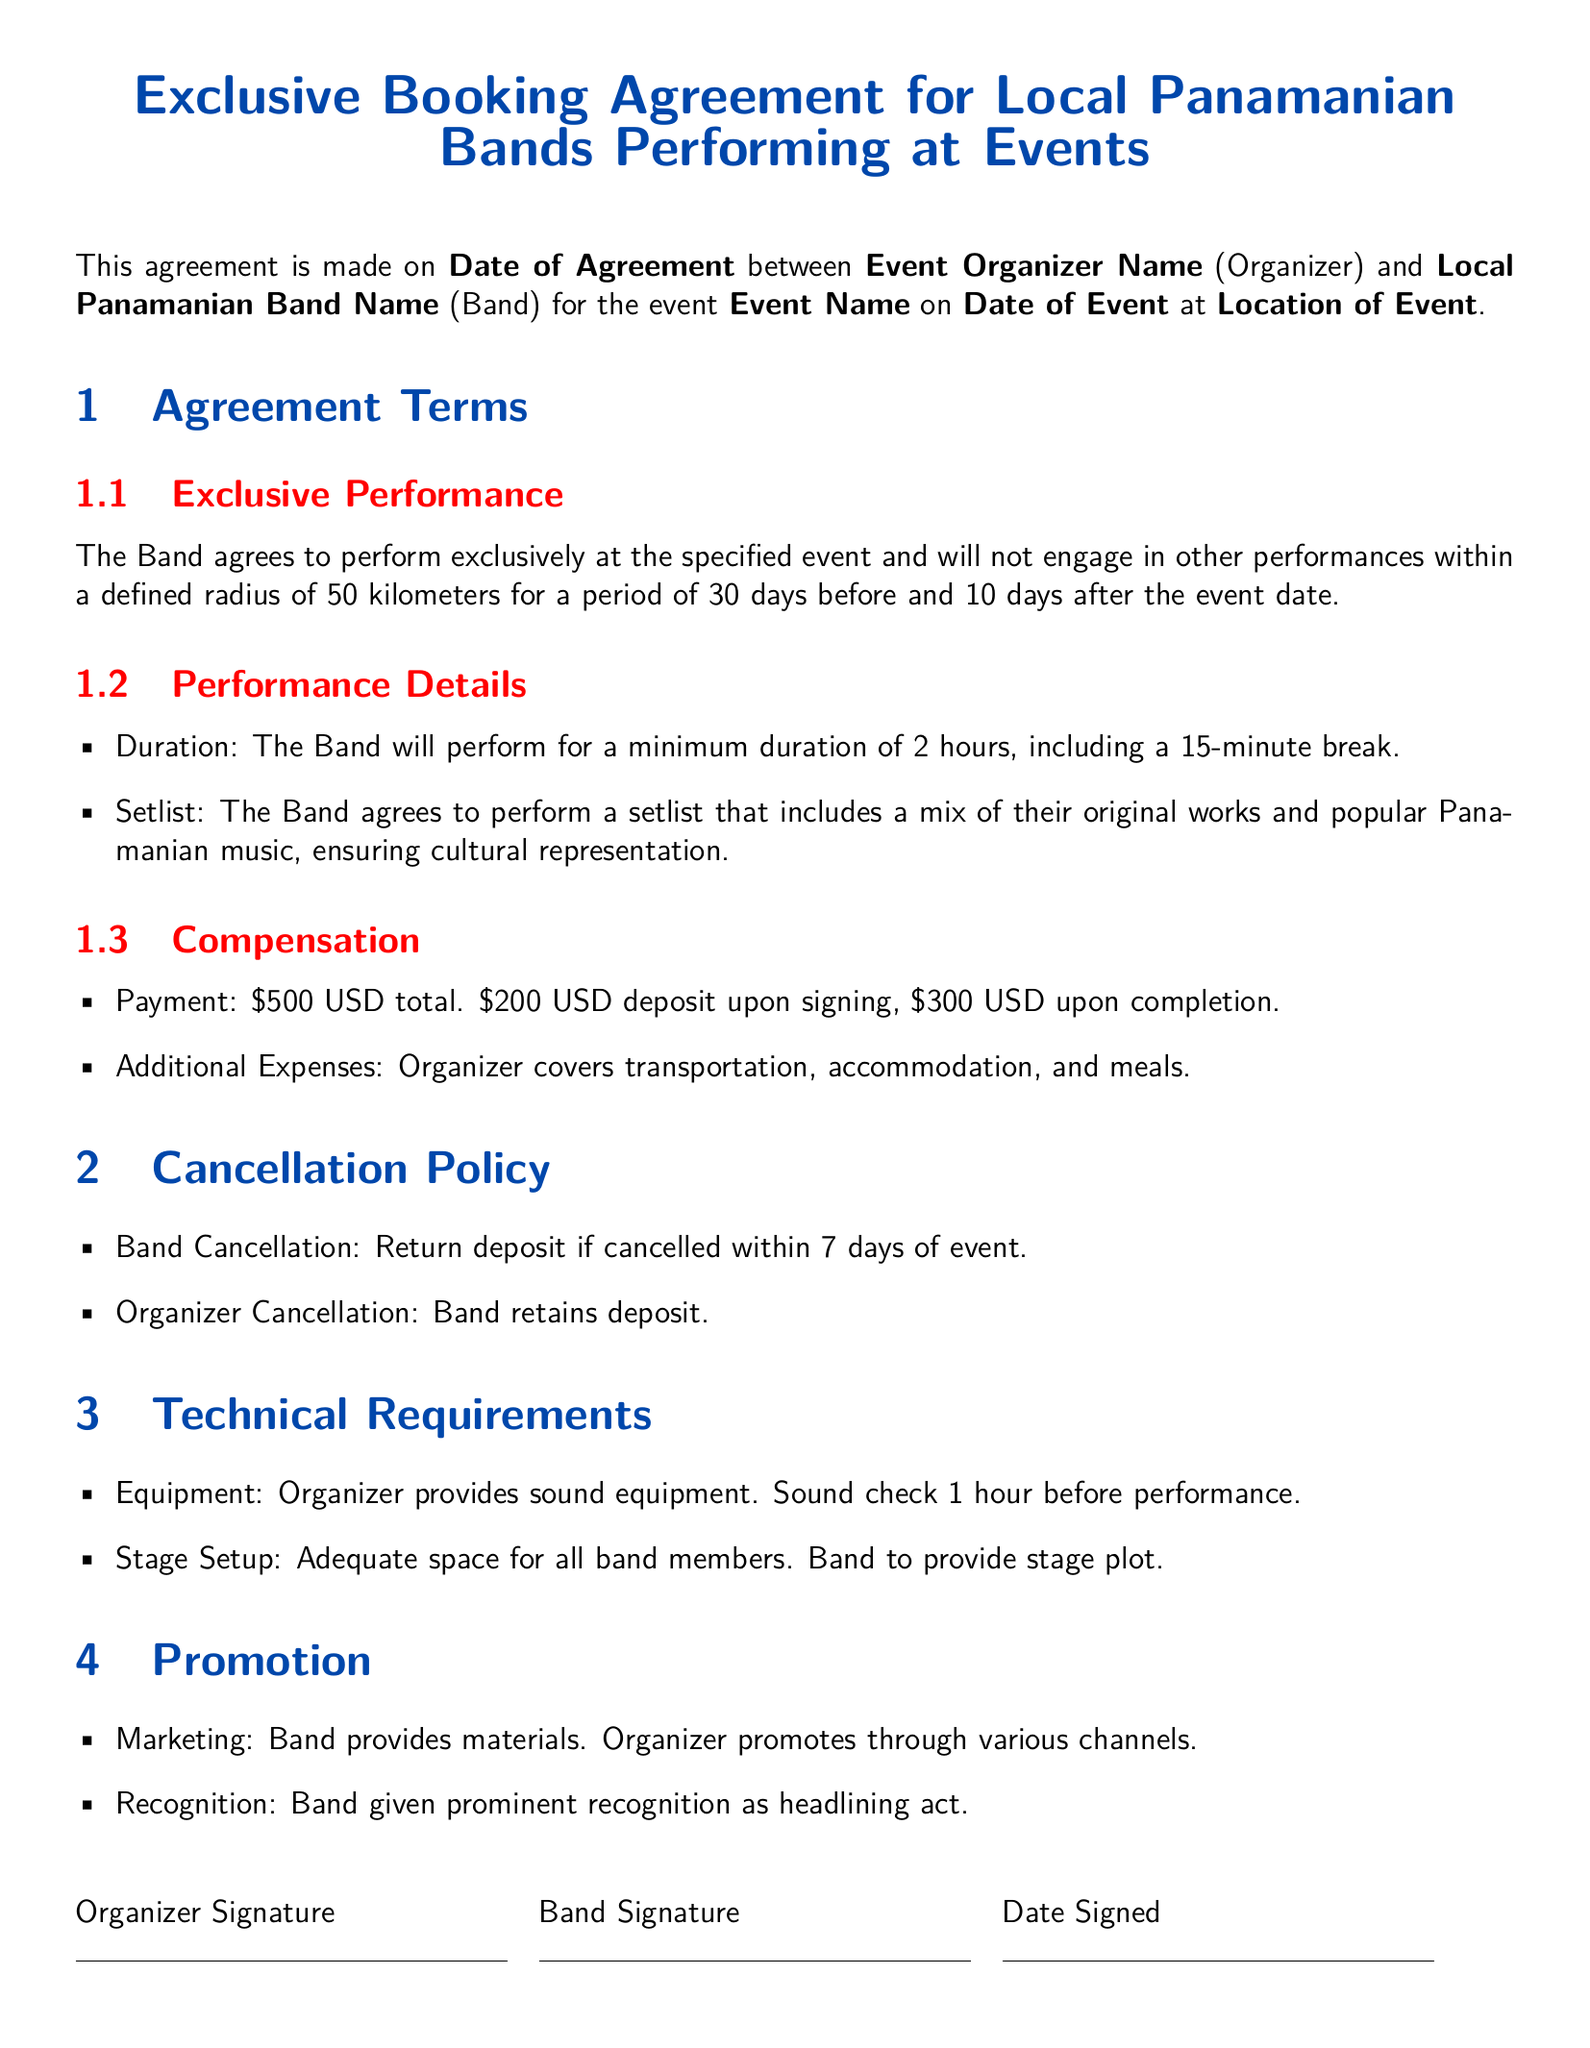What is the event date? The event date is specified in the section where the agreement details are outlined and should be filled in during the completion of the document.
Answer: Date of Event What is the performance duration? The performance duration is clearly defined as the minimum time the band is required to perform.
Answer: 2 hours What is the deposit amount? The deposit amount is explicitly stated under the compensation section of the agreement.
Answer: 200 USD What is the cancellation policy for the Band? The cancellation policy for the Band is outlined under the specific section regarding cancellations, indicating what happens if the Band cancels.
Answer: Return deposit if cancelled within 7 days of event Who covers additional expenses? The document states who is responsible for additional expenses related to the performance.
Answer: Organizer What is the defined radius for exclusive performance? The agreement specifies the geographic area in which the Band cannot perform after agreeing to this contract.
Answer: 50 kilometers How long before the event does the exclusive performance period begin? The contract specifies the duration of the exclusive performance period before the event.
Answer: 30 days What must the Band provide for the stage setup? The stage setup requirements specify what the Band needs to supply for its performance.
Answer: Stage plot 